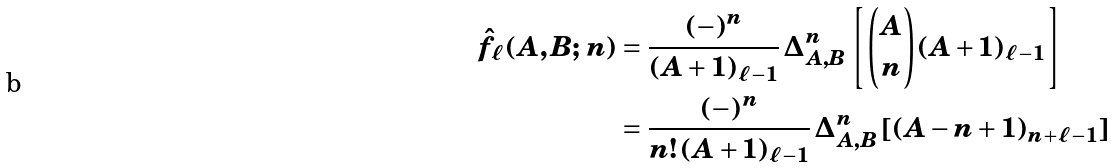<formula> <loc_0><loc_0><loc_500><loc_500>\hat { f } _ { \ell } ( A , B ; \, n ) & = \frac { ( - ) ^ { n } } { ( A + 1 ) _ { \ell - 1 } } \, \Delta _ { A , B } ^ { n } \left [ \binom { A } { n } ( A + 1 ) _ { \ell - 1 } \right ] \\ & = \frac { ( - ) ^ { n } } { n ! \, ( A + 1 ) _ { \ell - 1 } } \, \Delta _ { A , B } ^ { n } \left [ ( A - n + 1 ) _ { n + \ell - 1 } \right ]</formula> 